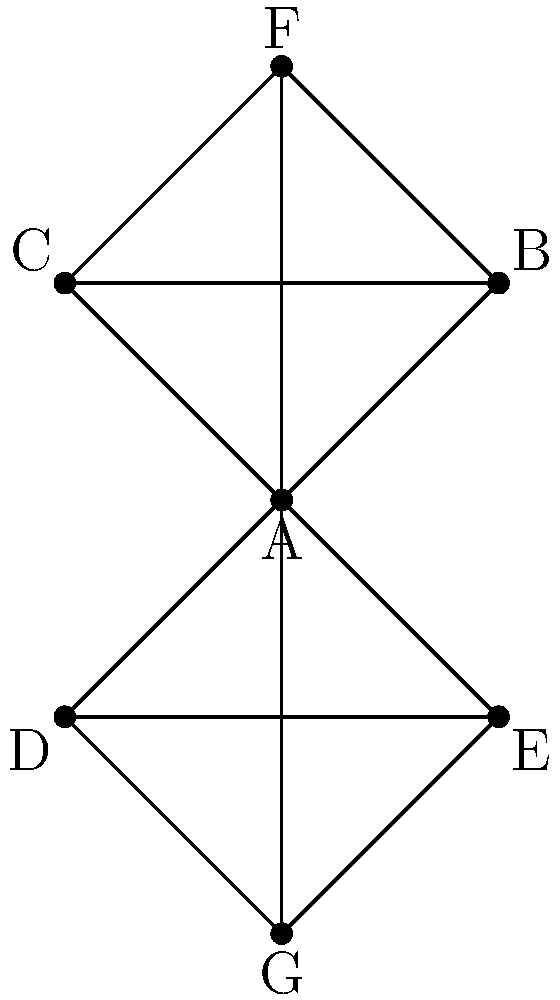In the given professional network graph of tech leaders, which node (individual) has the highest degree centrality, making them potentially the most influential in terms of direct connections? To determine the node with the highest degree centrality, we need to count the number of direct connections (edges) for each node:

1. Node A: Connected to 6 nodes (B, C, D, E, F, G)
2. Node B: Connected to 3 nodes (A, C, F)
3. Node C: Connected to 3 nodes (A, B, F)
4. Node D: Connected to 3 nodes (A, E, G)
5. Node E: Connected to 3 nodes (A, D, G)
6. Node F: Connected to 3 nodes (A, B, C)
7. Node G: Connected to 3 nodes (A, D, E)

Node A has the highest number of connections (6), while all other nodes have 3 connections each.

Degree centrality is a measure of the number of direct connections a node has in a network. In this case, Node A has the highest degree centrality, indicating that this individual has the most direct connections to other tech leaders in the network.

This suggests that Node A is potentially the most influential person in terms of direct connections, as they have the ability to reach more people directly within the network compared to any other individual.
Answer: Node A 